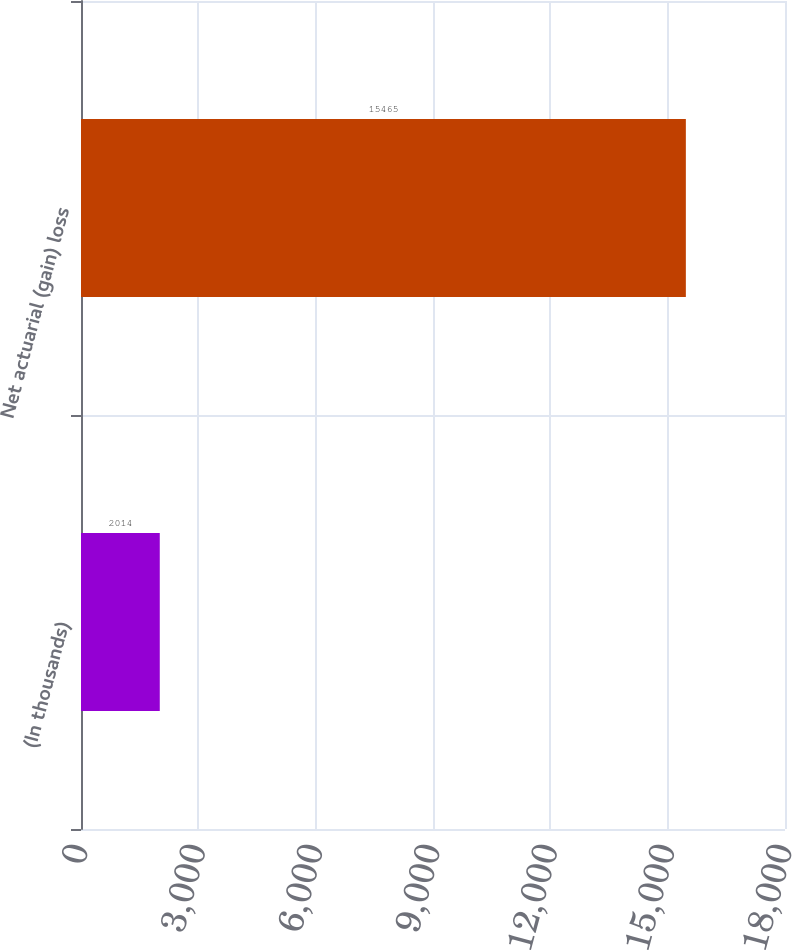Convert chart to OTSL. <chart><loc_0><loc_0><loc_500><loc_500><bar_chart><fcel>(In thousands)<fcel>Net actuarial (gain) loss<nl><fcel>2014<fcel>15465<nl></chart> 